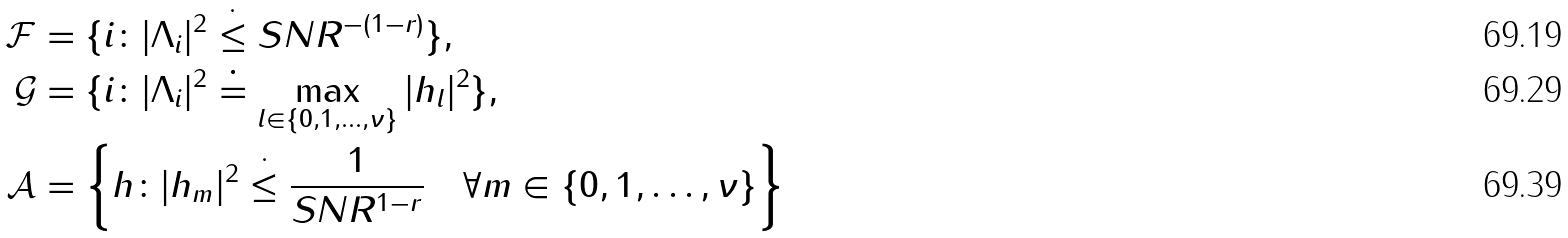<formula> <loc_0><loc_0><loc_500><loc_500>\mathcal { F } & = \{ i \colon | \Lambda _ { i } | ^ { 2 } \stackrel { \cdot } { \leq } S N R ^ { - ( 1 - r ) } \} , \\ \mathcal { G } & = \{ i \colon | \Lambda _ { i } | ^ { 2 } \doteq \max _ { l \in \{ 0 , 1 , \dots , \nu \} } | h _ { l } | ^ { 2 } \} , \\ \mathcal { A } & = \left \{ h \colon | h _ { m } | ^ { 2 } \stackrel { \cdot } { \leq } \frac { 1 } { S N R ^ { 1 - r } } \quad \forall m \in \{ 0 , 1 , \dots , \nu \} \right \}</formula> 